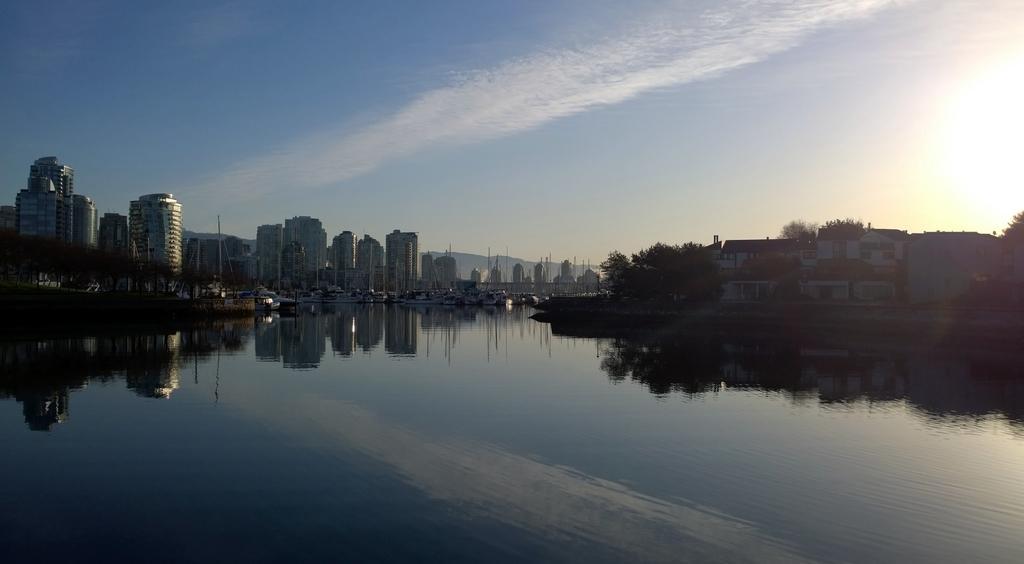Describe this image in one or two sentences. In the center of the image we can see the sky, clouds, buildings, trees, water and a few other objects. And we can see the reflections of a few objects on the water. 